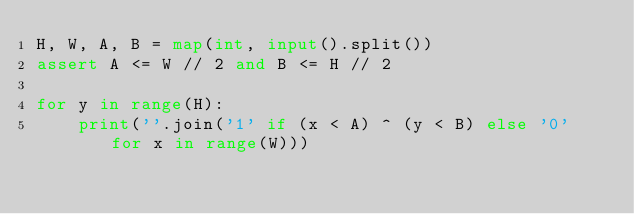Convert code to text. <code><loc_0><loc_0><loc_500><loc_500><_Python_>H, W, A, B = map(int, input().split())
assert A <= W // 2 and B <= H // 2

for y in range(H):
    print(''.join('1' if (x < A) ^ (y < B) else '0' for x in range(W)))</code> 